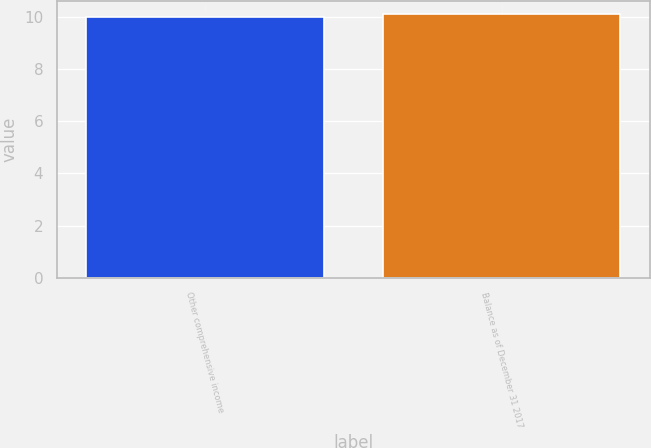Convert chart. <chart><loc_0><loc_0><loc_500><loc_500><bar_chart><fcel>Other comprehensive income<fcel>Balance as of December 31 2017<nl><fcel>10<fcel>10.1<nl></chart> 